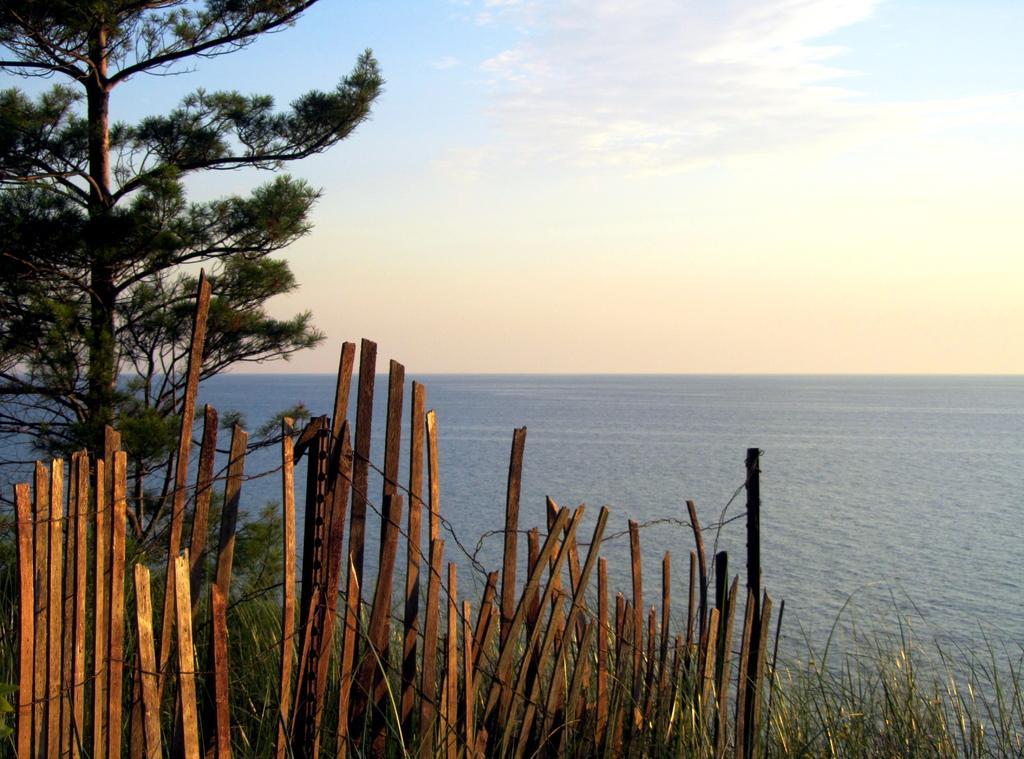Please provide a concise description of this image. In this image we can see wooden fence, grass, tree, water and sky with clouds in the background. 